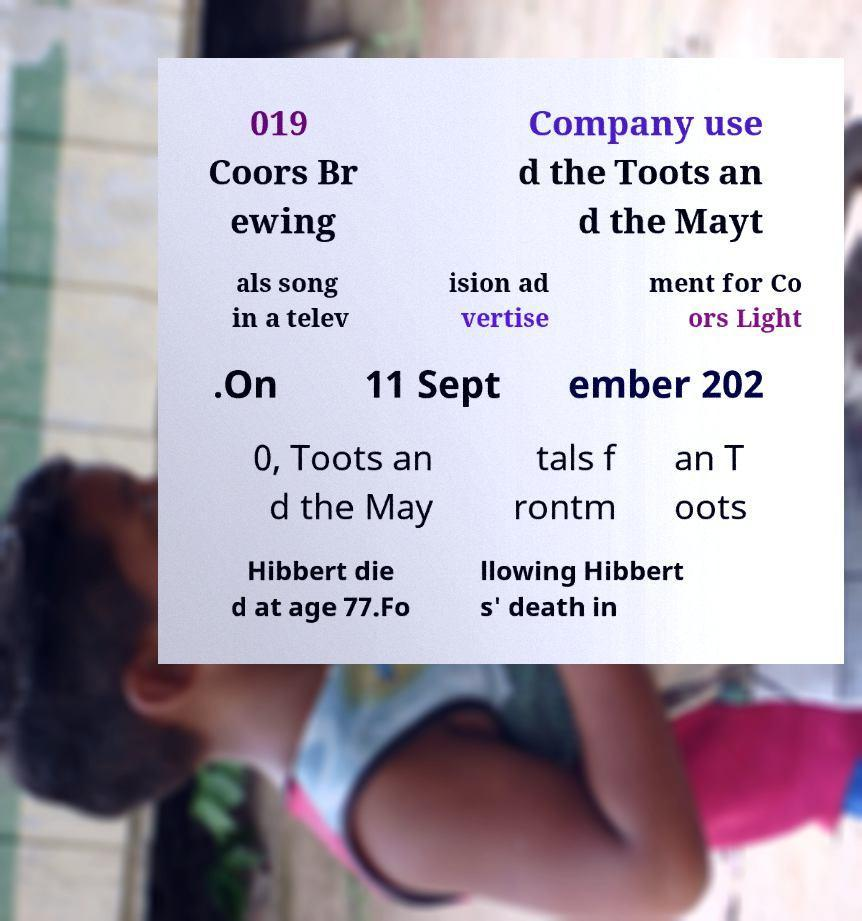Could you extract and type out the text from this image? 019 Coors Br ewing Company use d the Toots an d the Mayt als song in a telev ision ad vertise ment for Co ors Light .On 11 Sept ember 202 0, Toots an d the May tals f rontm an T oots Hibbert die d at age 77.Fo llowing Hibbert s' death in 